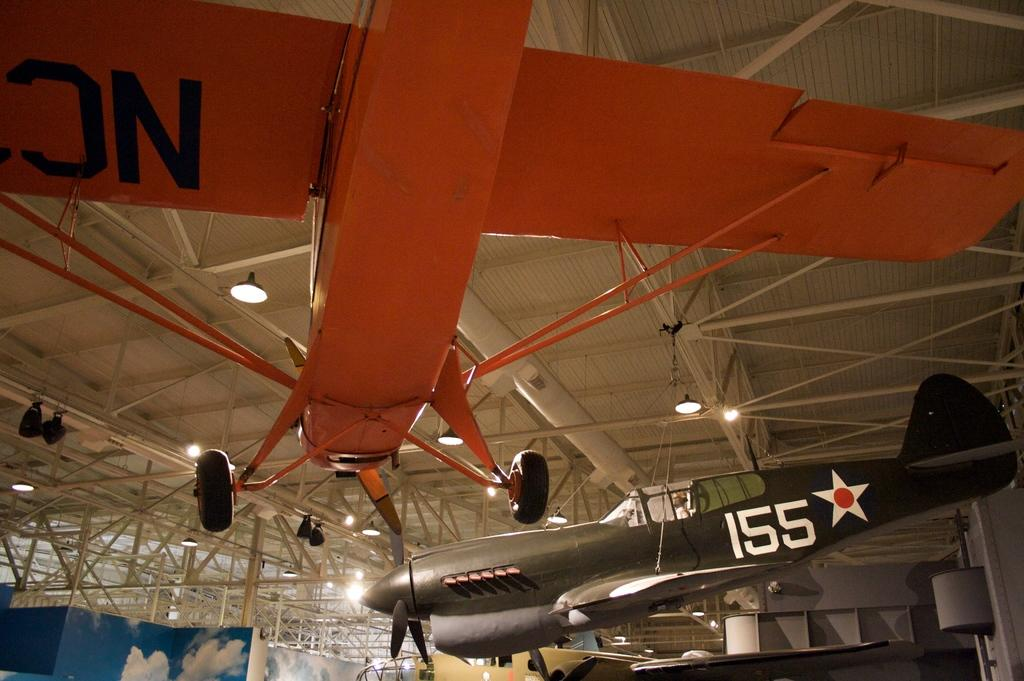<image>
Provide a brief description of the given image. Planes lettered with 155 and NC hang from the ceiling of a large open building. 